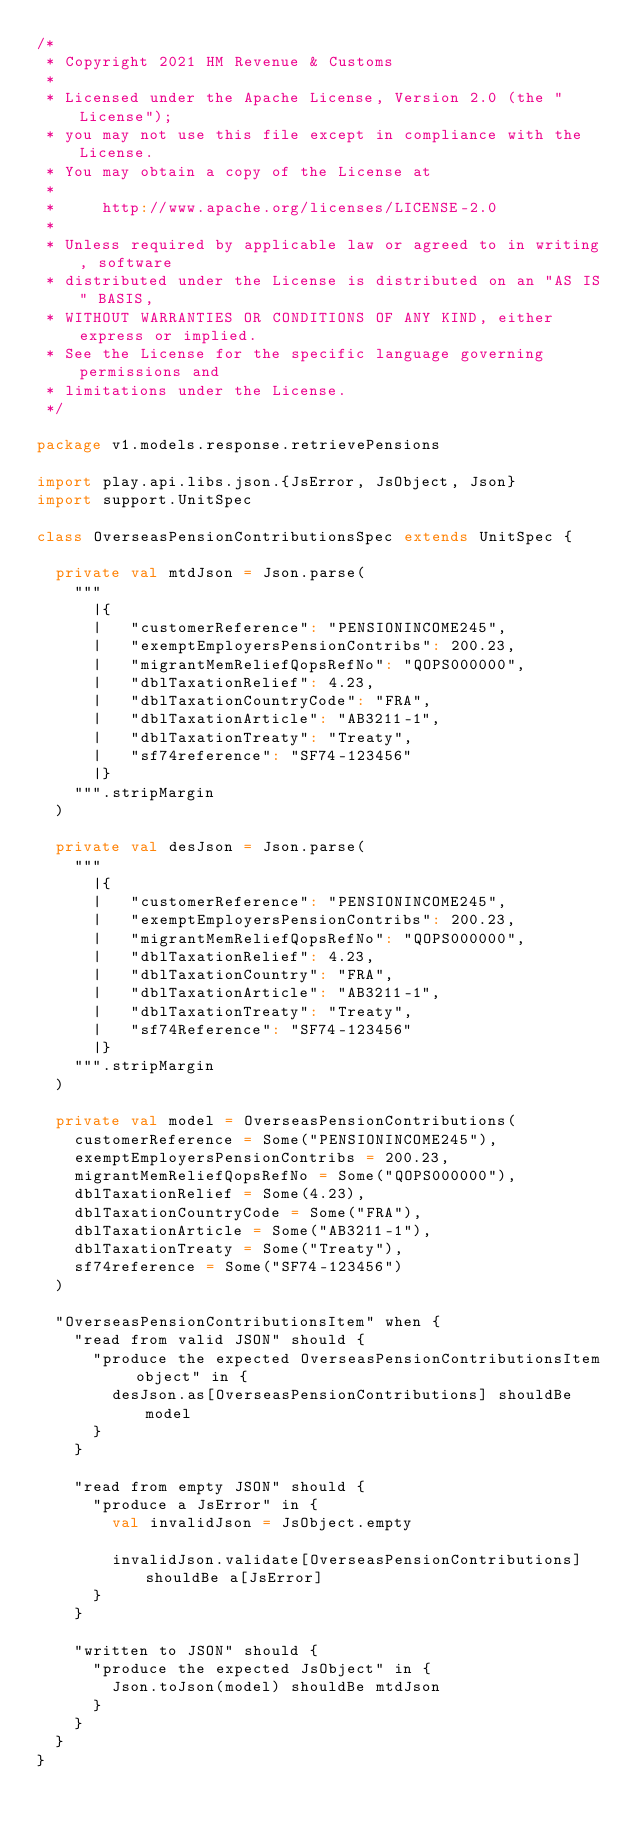Convert code to text. <code><loc_0><loc_0><loc_500><loc_500><_Scala_>/*
 * Copyright 2021 HM Revenue & Customs
 *
 * Licensed under the Apache License, Version 2.0 (the "License");
 * you may not use this file except in compliance with the License.
 * You may obtain a copy of the License at
 *
 *     http://www.apache.org/licenses/LICENSE-2.0
 *
 * Unless required by applicable law or agreed to in writing, software
 * distributed under the License is distributed on an "AS IS" BASIS,
 * WITHOUT WARRANTIES OR CONDITIONS OF ANY KIND, either express or implied.
 * See the License for the specific language governing permissions and
 * limitations under the License.
 */

package v1.models.response.retrievePensions

import play.api.libs.json.{JsError, JsObject, Json}
import support.UnitSpec

class OverseasPensionContributionsSpec extends UnitSpec {

  private val mtdJson = Json.parse(
    """
      |{
      |   "customerReference": "PENSIONINCOME245",
      |   "exemptEmployersPensionContribs": 200.23,
      |   "migrantMemReliefQopsRefNo": "QOPS000000",
      |   "dblTaxationRelief": 4.23,
      |   "dblTaxationCountryCode": "FRA",
      |   "dblTaxationArticle": "AB3211-1",
      |   "dblTaxationTreaty": "Treaty",
      |   "sf74reference": "SF74-123456"
      |}
    """.stripMargin
  )

  private val desJson = Json.parse(
    """
      |{
      |   "customerReference": "PENSIONINCOME245",
      |   "exemptEmployersPensionContribs": 200.23,
      |   "migrantMemReliefQopsRefNo": "QOPS000000",
      |   "dblTaxationRelief": 4.23,
      |   "dblTaxationCountry": "FRA",
      |   "dblTaxationArticle": "AB3211-1",
      |   "dblTaxationTreaty": "Treaty",
      |   "sf74Reference": "SF74-123456"
      |}
    """.stripMargin
  )

  private val model = OverseasPensionContributions(
    customerReference = Some("PENSIONINCOME245"),
    exemptEmployersPensionContribs = 200.23,
    migrantMemReliefQopsRefNo = Some("QOPS000000"),
    dblTaxationRelief = Some(4.23),
    dblTaxationCountryCode = Some("FRA"),
    dblTaxationArticle = Some("AB3211-1"),
    dblTaxationTreaty = Some("Treaty"),
    sf74reference = Some("SF74-123456")
  )

  "OverseasPensionContributionsItem" when {
    "read from valid JSON" should {
      "produce the expected OverseasPensionContributionsItem object" in {
        desJson.as[OverseasPensionContributions] shouldBe model
      }
    }

    "read from empty JSON" should {
      "produce a JsError" in {
        val invalidJson = JsObject.empty

        invalidJson.validate[OverseasPensionContributions] shouldBe a[JsError]
      }
    }

    "written to JSON" should {
      "produce the expected JsObject" in {
        Json.toJson(model) shouldBe mtdJson
      }
    }
  }
}
</code> 